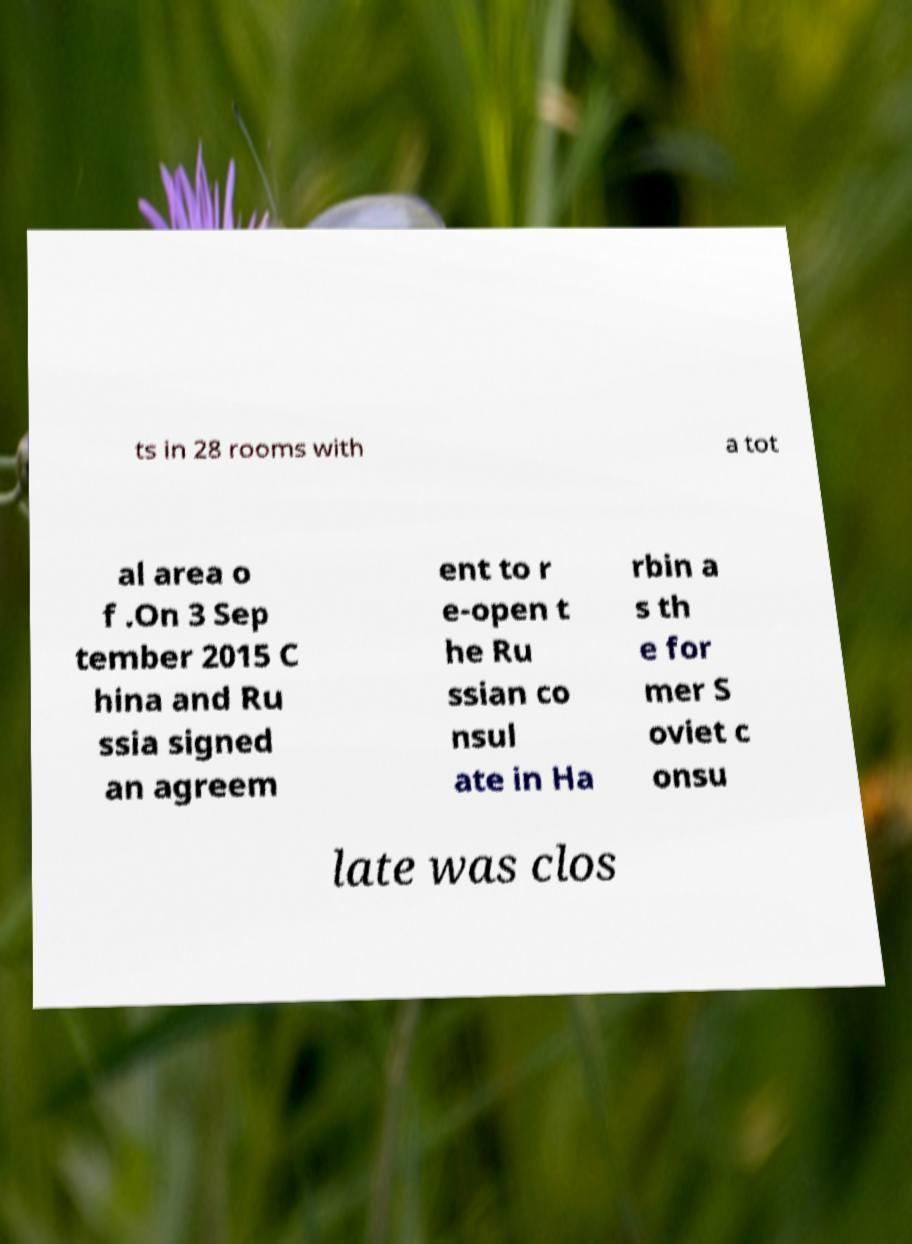Could you extract and type out the text from this image? ts in 28 rooms with a tot al area o f .On 3 Sep tember 2015 C hina and Ru ssia signed an agreem ent to r e-open t he Ru ssian co nsul ate in Ha rbin a s th e for mer S oviet c onsu late was clos 